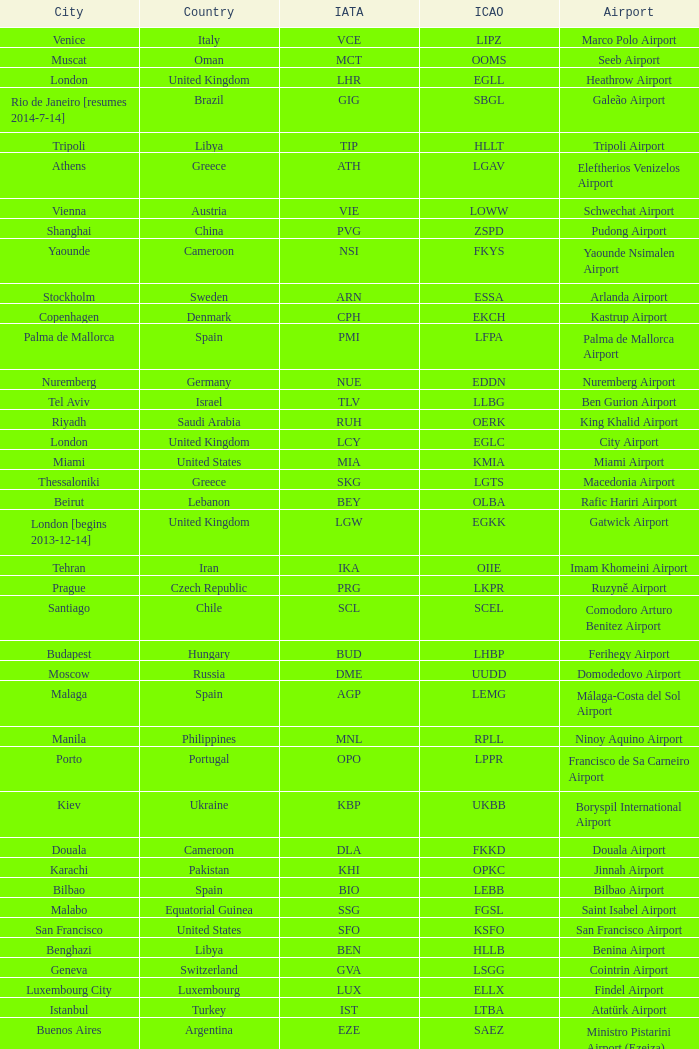Could you parse the entire table? {'header': ['City', 'Country', 'IATA', 'ICAO', 'Airport'], 'rows': [['Venice', 'Italy', 'VCE', 'LIPZ', 'Marco Polo Airport'], ['Muscat', 'Oman', 'MCT', 'OOMS', 'Seeb Airport'], ['London', 'United Kingdom', 'LHR', 'EGLL', 'Heathrow Airport'], ['Rio de Janeiro [resumes 2014-7-14]', 'Brazil', 'GIG', 'SBGL', 'Galeão Airport'], ['Tripoli', 'Libya', 'TIP', 'HLLT', 'Tripoli Airport'], ['Athens', 'Greece', 'ATH', 'LGAV', 'Eleftherios Venizelos Airport'], ['Vienna', 'Austria', 'VIE', 'LOWW', 'Schwechat Airport'], ['Shanghai', 'China', 'PVG', 'ZSPD', 'Pudong Airport'], ['Yaounde', 'Cameroon', 'NSI', 'FKYS', 'Yaounde Nsimalen Airport'], ['Stockholm', 'Sweden', 'ARN', 'ESSA', 'Arlanda Airport'], ['Copenhagen', 'Denmark', 'CPH', 'EKCH', 'Kastrup Airport'], ['Palma de Mallorca', 'Spain', 'PMI', 'LFPA', 'Palma de Mallorca Airport'], ['Nuremberg', 'Germany', 'NUE', 'EDDN', 'Nuremberg Airport'], ['Tel Aviv', 'Israel', 'TLV', 'LLBG', 'Ben Gurion Airport'], ['Riyadh', 'Saudi Arabia', 'RUH', 'OERK', 'King Khalid Airport'], ['London', 'United Kingdom', 'LCY', 'EGLC', 'City Airport'], ['Miami', 'United States', 'MIA', 'KMIA', 'Miami Airport'], ['Thessaloniki', 'Greece', 'SKG', 'LGTS', 'Macedonia Airport'], ['Beirut', 'Lebanon', 'BEY', 'OLBA', 'Rafic Hariri Airport'], ['London [begins 2013-12-14]', 'United Kingdom', 'LGW', 'EGKK', 'Gatwick Airport'], ['Tehran', 'Iran', 'IKA', 'OIIE', 'Imam Khomeini Airport'], ['Prague', 'Czech Republic', 'PRG', 'LKPR', 'Ruzyně Airport'], ['Santiago', 'Chile', 'SCL', 'SCEL', 'Comodoro Arturo Benitez Airport'], ['Budapest', 'Hungary', 'BUD', 'LHBP', 'Ferihegy Airport'], ['Moscow', 'Russia', 'DME', 'UUDD', 'Domodedovo Airport'], ['Malaga', 'Spain', 'AGP', 'LEMG', 'Málaga-Costa del Sol Airport'], ['Manila', 'Philippines', 'MNL', 'RPLL', 'Ninoy Aquino Airport'], ['Porto', 'Portugal', 'OPO', 'LPPR', 'Francisco de Sa Carneiro Airport'], ['Kiev', 'Ukraine', 'KBP', 'UKBB', 'Boryspil International Airport'], ['Douala', 'Cameroon', 'DLA', 'FKKD', 'Douala Airport'], ['Karachi', 'Pakistan', 'KHI', 'OPKC', 'Jinnah Airport'], ['Bilbao', 'Spain', 'BIO', 'LEBB', 'Bilbao Airport'], ['Malabo', 'Equatorial Guinea', 'SSG', 'FGSL', 'Saint Isabel Airport'], ['San Francisco', 'United States', 'SFO', 'KSFO', 'San Francisco Airport'], ['Benghazi', 'Libya', 'BEN', 'HLLB', 'Benina Airport'], ['Geneva', 'Switzerland', 'GVA', 'LSGG', 'Cointrin Airport'], ['Luxembourg City', 'Luxembourg', 'LUX', 'ELLX', 'Findel Airport'], ['Istanbul', 'Turkey', 'IST', 'LTBA', 'Atatürk Airport'], ['Buenos Aires', 'Argentina', 'EZE', 'SAEZ', 'Ministro Pistarini Airport (Ezeiza)'], ['Frankfurt', 'Germany', 'FRA', 'EDDF', 'Frankfurt am Main Airport'], ['Jakarta', 'Indonesia', 'CGK', 'WIII', 'Soekarno–Hatta Airport'], ['Dublin', 'Ireland', 'DUB', 'EIDW', 'Dublin Airport'], ['Lagos', 'Nigeria', 'LOS', 'DNMM', 'Murtala Muhammed Airport'], ['Newark', 'United States', 'EWR', 'KEWR', 'Liberty Airport'], ['Skopje', 'Republic of Macedonia', 'SKP', 'LWSK', 'Alexander the Great Airport'], ['Zurich', 'Switzerland', 'ZRH', 'LSZH', 'Zurich Airport'], ['Paris', 'France', 'CDG', 'LFPG', 'Charles de Gaulle Airport'], ['Chicago', 'United States', 'ORD', 'KORD', "O'Hare Airport"], ['Riga', 'Latvia', 'RIX', 'EVRA', 'Riga Airport'], ['Nice', 'France', 'NCE', 'LFMN', "Côte d'Azur Airport"], ['Berlin', 'Germany', 'TXL', 'EDDT', 'Tegel Airport'], ['Tunis', 'Tunisia', 'TUN', 'DTTA', 'Carthage Airport'], ['Dubai', 'United Arab Emirates', 'DXB', 'OMDB', 'Dubai Airport'], ['Saint Petersburg', 'Russia', 'LED', 'ULLI', 'Pulkovo Airport'], ['Tokyo', 'Japan', 'NRT', 'RJAA', 'Narita Airport'], ['Genoa', 'Italy', 'GOA', 'LIMJ', 'Cristoforo Colombo Airport'], ['Atlanta', 'United States', 'ATL', 'KATL', 'Hartsfield–Jackson Airport'], ['Belgrade', 'Serbia', 'BEG', 'LYBE', 'Nikola Tesla Airport'], ['Madrid', 'Spain', 'MAD', 'LEMD', 'Madrid-Barajas Airport'], ['Oslo', 'Norway', 'OSL', 'ENGM', 'Gardermoen Airport'], ['Nairobi', 'Kenya', 'NBO', 'HKJK', 'Jomo Kenyatta Airport'], ['Seattle', 'United States', 'SEA', 'KSEA', 'Sea-Tac Airport'], ['Munich', 'Germany', 'MUC', 'EDDM', 'Franz Josef Strauss Airport'], ['Johannesburg', 'South Africa', 'JNB', 'FAJS', 'OR Tambo Airport'], ['Cairo', 'Egypt', 'CAI', 'HECA', 'Cairo Airport'], ['Hong Kong', 'Hong Kong', 'HKG', 'VHHH', 'Chek Lap Kok Airport'], ['Valencia', 'Spain', 'VLC', 'LEVC', 'Valencia Airport'], ['Marrakech [begins 2013-11-01]', 'Morocco', 'RAK', 'GMMX', 'Menara Airport'], ['Montreal', 'Canada', 'YUL', 'CYUL', 'Pierre Elliott Trudeau Airport'], ['São Paulo', 'Brazil', 'GRU', 'SBGR', 'Guarulhos Airport'], ['Caracas', 'Venezuela', 'CCS', 'SVMI', 'Simón Bolívar Airport'], ['Libreville', 'Gabon', 'LBV', 'FOOL', "Leon M'ba Airport"], ['Delhi', 'India', 'DEL', 'VIDP', 'Indira Gandhi Airport'], ['Rome', 'Italy', 'FCO', 'LIRF', 'Leonardo da Vinci Airport'], ['New York City', 'United States', 'JFK', 'KJFK', 'John F Kennedy Airport'], ['Abu Dhabi', 'United Arab Emirates', 'AUH', 'OMAA', 'Abu Dhabi Airport'], ['Toronto', 'Canada', 'YYZ', 'CYYZ', 'Pearson Airport'], ['Boston', 'United States', 'BOS', 'KBOS', 'Logan Airport'], ['Gothenburg [begins 2013-12-14]', 'Sweden', 'GOT', 'ESGG', 'Gothenburg-Landvetter Airport'], ['Hamburg', 'Germany', 'HAM', 'EDDH', 'Fuhlsbüttel Airport'], ['Tirana', 'Albania', 'TIA', 'LATI', 'Nënë Tereza Airport'], ['Singapore', 'Singapore', 'SIN', 'WSSS', 'Changi Airport'], ['Ho Chi Minh City', 'Vietnam', 'SGN', 'VVTS', 'Tan Son Nhat Airport'], ['Washington DC', 'United States', 'IAD', 'KIAD', 'Dulles Airport'], ['Sarajevo', 'Bosnia and Herzegovina', 'SJJ', 'LQSA', 'Butmir Airport'], ['Minneapolis', 'United States', 'MSP', 'KMSP', 'Minneapolis Airport'], ['Lisbon', 'Portugal', 'LIS', 'LPPT', 'Portela Airport'], ['Sofia', 'Bulgaria', 'SOF', 'LBSF', 'Vrazhdebna Airport'], ['Milan', 'Italy', 'MXP', 'LIMC', 'Malpensa Airport'], ['Basel Mulhouse Freiburg', 'Switzerland France Germany', 'BSL MLH EAP', 'LFSB', 'Euro Airport'], ['Birmingham', 'United Kingdom', 'BHX', 'EGBB', 'Birmingham Airport'], ['Turin', 'Italy', 'TRN', 'LIMF', 'Sandro Pertini Airport'], ['Lugano', 'Switzerland', 'LUG', 'LSZA', 'Agno Airport'], ['Barcelona', 'Spain', 'BCN', 'LEBL', 'Barcelona-El Prat Airport'], ['Hannover', 'Germany', 'HAJ', 'EDDV', 'Langenhagen Airport'], ['Helsinki', 'Finland', 'HEL', 'EFHK', 'Vantaa Airport'], ['Beijing', 'China', 'PEK', 'ZBAA', 'Capital Airport'], ['Bucharest', 'Romania', 'OTP', 'LROP', 'Otopeni Airport'], ['Los Angeles', 'United States', 'LAX', 'KLAX', 'Los Angeles International Airport'], ['Yerevan', 'Armenia', 'EVN', 'UDYZ', 'Zvartnots Airport'], ['Manchester', 'United Kingdom', 'MAN', 'EGCC', 'Ringway Airport'], ['Mumbai', 'India', 'BOM', 'VABB', 'Chhatrapati Shivaji Airport'], ['Bangkok', 'Thailand', 'BKK', 'VTBS', 'Suvarnabhumi Airport'], ['Düsseldorf', 'Germany', 'DUS', 'EDDL', 'Lohausen Airport'], ['Accra', 'Ghana', 'ACC', 'DGAA', 'Kotoka Airport'], ['Warsaw', 'Poland', 'WAW', 'EPWA', 'Frederic Chopin Airport'], ['Amsterdam', 'Netherlands', 'AMS', 'EHAM', 'Amsterdam Airport Schiphol'], ['Taipei', 'Taiwan', 'TPE', 'RCTP', 'Taoyuan Airport'], ['Jeddah', 'Saudi Arabia', 'JED', 'OEJN', 'King Abdulaziz Airport'], ['Casablanca', 'Morocco', 'CMN', 'GMMN', 'Mohammed V Airport'], ['Lyon', 'France', 'LYS', 'LFLL', 'Saint-Exupéry Airport'], ['Brussels', 'Belgium', 'BRU', 'EBBR', 'Brussels Airport'], ['Dar es Salaam', 'Tanzania', 'DAR', 'HTDA', 'Julius Nyerere Airport'], ['Stuttgart', 'Germany', 'STR', 'EDDS', 'Echterdingen Airport'], ['Florence', 'Italy', 'FLR', 'LIRQ', 'Peretola Airport']]} What is the ICAO of Lohausen airport? EDDL. 